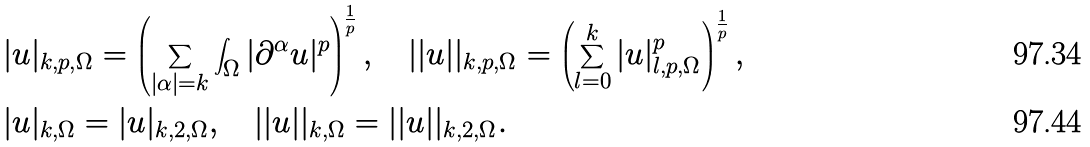<formula> <loc_0><loc_0><loc_500><loc_500>& | u | _ { k , p , \Omega } = \left ( \sum _ { | \alpha | = k } \int _ { \Omega } | \partial ^ { \alpha } u | ^ { p } \right ) ^ { \frac { 1 } { p } } , \quad | | u | | _ { k , p , \Omega } = \left ( \sum _ { l = 0 } ^ { k } | u | _ { l , p , \Omega } ^ { p } \right ) ^ { \frac { 1 } { p } } , \\ & | u | _ { k , \Omega } = | u | _ { k , 2 , \Omega } , \quad | | u | | _ { k , \Omega } = | | u | | _ { k , 2 , \Omega } .</formula> 